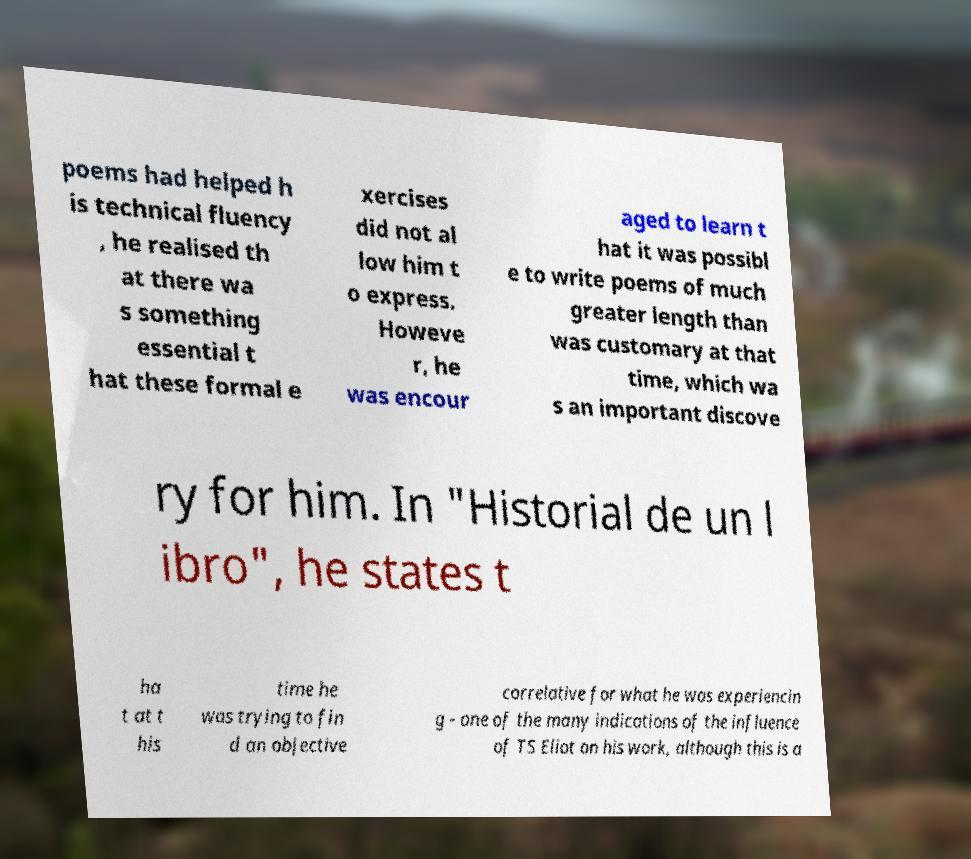Please identify and transcribe the text found in this image. poems had helped h is technical fluency , he realised th at there wa s something essential t hat these formal e xercises did not al low him t o express. Howeve r, he was encour aged to learn t hat it was possibl e to write poems of much greater length than was customary at that time, which wa s an important discove ry for him. In "Historial de un l ibro", he states t ha t at t his time he was trying to fin d an objective correlative for what he was experiencin g - one of the many indications of the influence of TS Eliot on his work, although this is a 